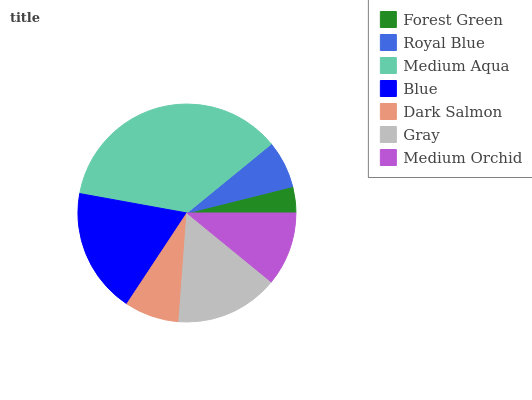Is Forest Green the minimum?
Answer yes or no. Yes. Is Medium Aqua the maximum?
Answer yes or no. Yes. Is Royal Blue the minimum?
Answer yes or no. No. Is Royal Blue the maximum?
Answer yes or no. No. Is Royal Blue greater than Forest Green?
Answer yes or no. Yes. Is Forest Green less than Royal Blue?
Answer yes or no. Yes. Is Forest Green greater than Royal Blue?
Answer yes or no. No. Is Royal Blue less than Forest Green?
Answer yes or no. No. Is Medium Orchid the high median?
Answer yes or no. Yes. Is Medium Orchid the low median?
Answer yes or no. Yes. Is Royal Blue the high median?
Answer yes or no. No. Is Blue the low median?
Answer yes or no. No. 